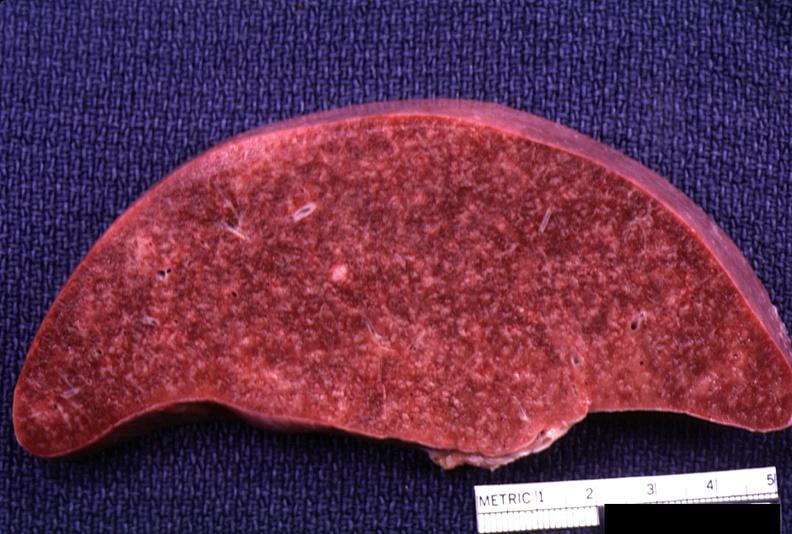does this image show spleen, lymphoma?
Answer the question using a single word or phrase. Yes 